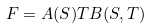Convert formula to latex. <formula><loc_0><loc_0><loc_500><loc_500>F = A ( S ) T B ( S , T )</formula> 